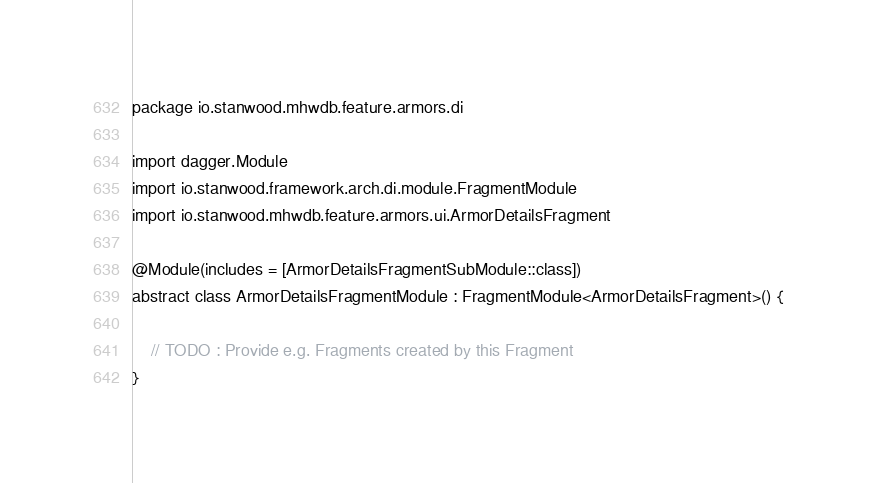<code> <loc_0><loc_0><loc_500><loc_500><_Kotlin_>package io.stanwood.mhwdb.feature.armors.di

import dagger.Module
import io.stanwood.framework.arch.di.module.FragmentModule
import io.stanwood.mhwdb.feature.armors.ui.ArmorDetailsFragment

@Module(includes = [ArmorDetailsFragmentSubModule::class])
abstract class ArmorDetailsFragmentModule : FragmentModule<ArmorDetailsFragment>() {

    // TODO : Provide e.g. Fragments created by this Fragment
}</code> 